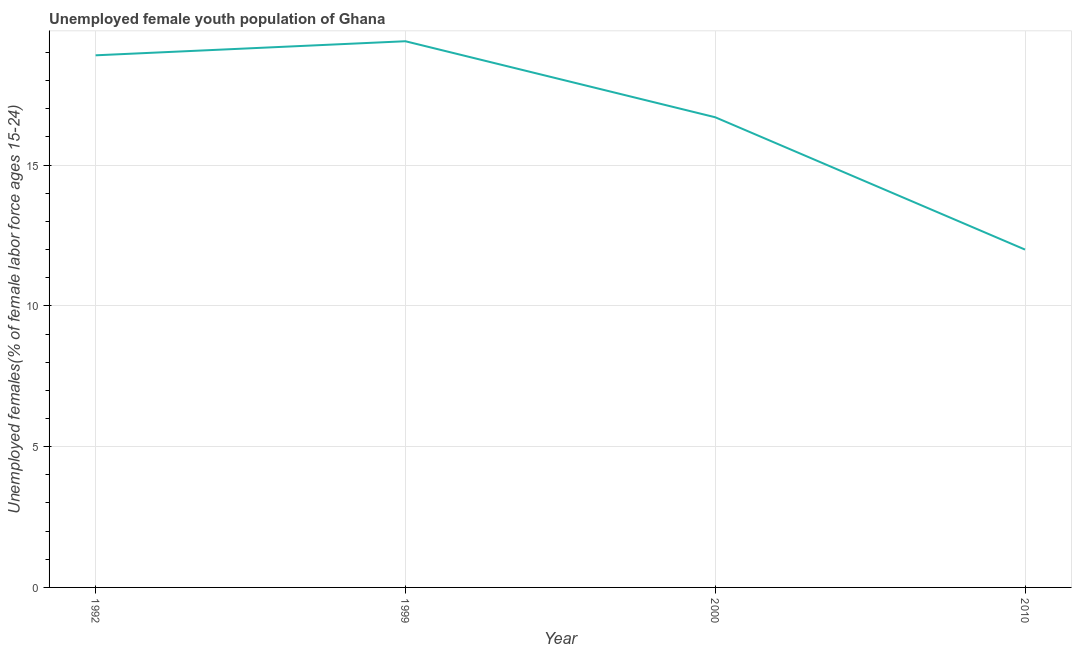What is the unemployed female youth in 2010?
Your answer should be very brief. 12. Across all years, what is the maximum unemployed female youth?
Give a very brief answer. 19.4. In which year was the unemployed female youth maximum?
Your answer should be compact. 1999. What is the sum of the unemployed female youth?
Your answer should be compact. 67. What is the difference between the unemployed female youth in 1999 and 2000?
Your answer should be compact. 2.7. What is the average unemployed female youth per year?
Ensure brevity in your answer.  16.75. What is the median unemployed female youth?
Ensure brevity in your answer.  17.8. What is the ratio of the unemployed female youth in 1999 to that in 2000?
Provide a succinct answer. 1.16. Is the unemployed female youth in 2000 less than that in 2010?
Keep it short and to the point. No. Is the difference between the unemployed female youth in 1992 and 1999 greater than the difference between any two years?
Your response must be concise. No. What is the difference between the highest and the lowest unemployed female youth?
Provide a short and direct response. 7.4. In how many years, is the unemployed female youth greater than the average unemployed female youth taken over all years?
Your response must be concise. 2. Does the unemployed female youth monotonically increase over the years?
Offer a terse response. No. What is the difference between two consecutive major ticks on the Y-axis?
Give a very brief answer. 5. Are the values on the major ticks of Y-axis written in scientific E-notation?
Your answer should be compact. No. What is the title of the graph?
Keep it short and to the point. Unemployed female youth population of Ghana. What is the label or title of the Y-axis?
Your answer should be very brief. Unemployed females(% of female labor force ages 15-24). What is the Unemployed females(% of female labor force ages 15-24) in 1992?
Offer a terse response. 18.9. What is the Unemployed females(% of female labor force ages 15-24) of 1999?
Your answer should be compact. 19.4. What is the Unemployed females(% of female labor force ages 15-24) of 2000?
Ensure brevity in your answer.  16.7. What is the difference between the Unemployed females(% of female labor force ages 15-24) in 1992 and 2010?
Make the answer very short. 6.9. What is the difference between the Unemployed females(% of female labor force ages 15-24) in 2000 and 2010?
Your answer should be compact. 4.7. What is the ratio of the Unemployed females(% of female labor force ages 15-24) in 1992 to that in 2000?
Offer a very short reply. 1.13. What is the ratio of the Unemployed females(% of female labor force ages 15-24) in 1992 to that in 2010?
Your answer should be very brief. 1.57. What is the ratio of the Unemployed females(% of female labor force ages 15-24) in 1999 to that in 2000?
Provide a short and direct response. 1.16. What is the ratio of the Unemployed females(% of female labor force ages 15-24) in 1999 to that in 2010?
Keep it short and to the point. 1.62. What is the ratio of the Unemployed females(% of female labor force ages 15-24) in 2000 to that in 2010?
Your answer should be very brief. 1.39. 